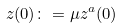Convert formula to latex. <formula><loc_0><loc_0><loc_500><loc_500>z ( 0 ) \colon = \mu z ^ { a } ( 0 )</formula> 